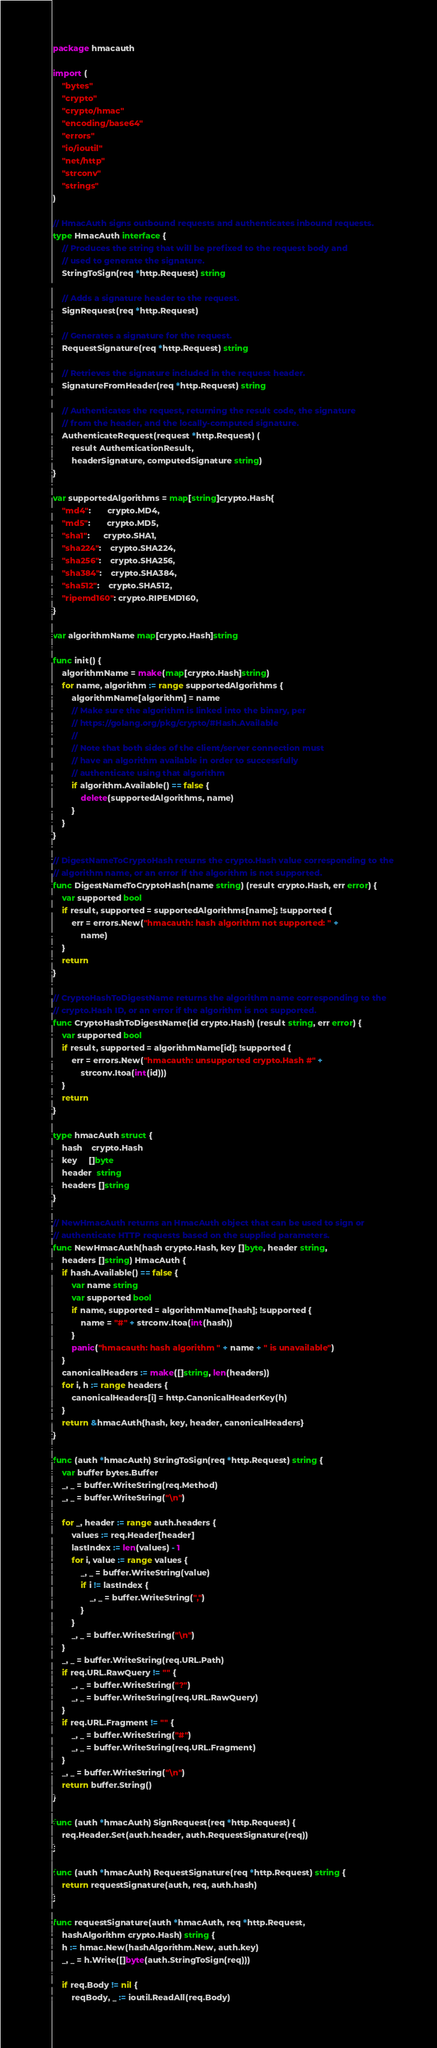Convert code to text. <code><loc_0><loc_0><loc_500><loc_500><_Go_>package hmacauth

import (
	"bytes"
	"crypto"
	"crypto/hmac"
	"encoding/base64"
	"errors"
	"io/ioutil"
	"net/http"
	"strconv"
	"strings"
)

// HmacAuth signs outbound requests and authenticates inbound requests.
type HmacAuth interface {
	// Produces the string that will be prefixed to the request body and
	// used to generate the signature.
	StringToSign(req *http.Request) string

	// Adds a signature header to the request.
	SignRequest(req *http.Request)

	// Generates a signature for the request.
	RequestSignature(req *http.Request) string

	// Retrieves the signature included in the request header.
	SignatureFromHeader(req *http.Request) string

	// Authenticates the request, returning the result code, the signature
	// from the header, and the locally-computed signature.
	AuthenticateRequest(request *http.Request) (
		result AuthenticationResult,
		headerSignature, computedSignature string)
}

var supportedAlgorithms = map[string]crypto.Hash{
	"md4":       crypto.MD4,
	"md5":       crypto.MD5,
	"sha1":      crypto.SHA1,
	"sha224":    crypto.SHA224,
	"sha256":    crypto.SHA256,
	"sha384":    crypto.SHA384,
	"sha512":    crypto.SHA512,
	"ripemd160": crypto.RIPEMD160,
}

var algorithmName map[crypto.Hash]string

func init() {
	algorithmName = make(map[crypto.Hash]string)
	for name, algorithm := range supportedAlgorithms {
		algorithmName[algorithm] = name
		// Make sure the algorithm is linked into the binary, per
		// https://golang.org/pkg/crypto/#Hash.Available
		//
		// Note that both sides of the client/server connection must
		// have an algorithm available in order to successfully
		// authenticate using that algorithm
		if algorithm.Available() == false {
			delete(supportedAlgorithms, name)
		}
	}
}

// DigestNameToCryptoHash returns the crypto.Hash value corresponding to the
// algorithm name, or an error if the algorithm is not supported.
func DigestNameToCryptoHash(name string) (result crypto.Hash, err error) {
	var supported bool
	if result, supported = supportedAlgorithms[name]; !supported {
		err = errors.New("hmacauth: hash algorithm not supported: " +
			name)
	}
	return
}

// CryptoHashToDigestName returns the algorithm name corresponding to the
// crypto.Hash ID, or an error if the algorithm is not supported.
func CryptoHashToDigestName(id crypto.Hash) (result string, err error) {
	var supported bool
	if result, supported = algorithmName[id]; !supported {
		err = errors.New("hmacauth: unsupported crypto.Hash #" +
			strconv.Itoa(int(id)))
	}
	return
}

type hmacAuth struct {
	hash    crypto.Hash
	key     []byte
	header  string
	headers []string
}

// NewHmacAuth returns an HmacAuth object that can be used to sign or
// authenticate HTTP requests based on the supplied parameters.
func NewHmacAuth(hash crypto.Hash, key []byte, header string,
	headers []string) HmacAuth {
	if hash.Available() == false {
		var name string
		var supported bool
		if name, supported = algorithmName[hash]; !supported {
			name = "#" + strconv.Itoa(int(hash))
		}
		panic("hmacauth: hash algorithm " + name + " is unavailable")
	}
	canonicalHeaders := make([]string, len(headers))
	for i, h := range headers {
		canonicalHeaders[i] = http.CanonicalHeaderKey(h)
	}
	return &hmacAuth{hash, key, header, canonicalHeaders}
}

func (auth *hmacAuth) StringToSign(req *http.Request) string {
	var buffer bytes.Buffer
	_, _ = buffer.WriteString(req.Method)
	_, _ = buffer.WriteString("\n")

	for _, header := range auth.headers {
		values := req.Header[header]
		lastIndex := len(values) - 1
		for i, value := range values {
			_, _ = buffer.WriteString(value)
			if i != lastIndex {
				_, _ = buffer.WriteString(",")
			}
		}
		_, _ = buffer.WriteString("\n")
	}
	_, _ = buffer.WriteString(req.URL.Path)
	if req.URL.RawQuery != "" {
		_, _ = buffer.WriteString("?")
		_, _ = buffer.WriteString(req.URL.RawQuery)
	}
	if req.URL.Fragment != "" {
		_, _ = buffer.WriteString("#")
		_, _ = buffer.WriteString(req.URL.Fragment)
	}
	_, _ = buffer.WriteString("\n")
	return buffer.String()
}

func (auth *hmacAuth) SignRequest(req *http.Request) {
	req.Header.Set(auth.header, auth.RequestSignature(req))
}

func (auth *hmacAuth) RequestSignature(req *http.Request) string {
	return requestSignature(auth, req, auth.hash)
}

func requestSignature(auth *hmacAuth, req *http.Request,
	hashAlgorithm crypto.Hash) string {
	h := hmac.New(hashAlgorithm.New, auth.key)
	_, _ = h.Write([]byte(auth.StringToSign(req)))

	if req.Body != nil {
		reqBody, _ := ioutil.ReadAll(req.Body)</code> 